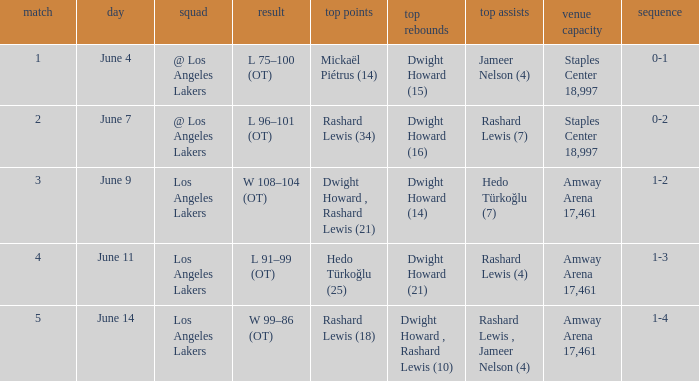What is High Points, when High Rebounds is "Dwight Howard (16)"? Rashard Lewis (34). 